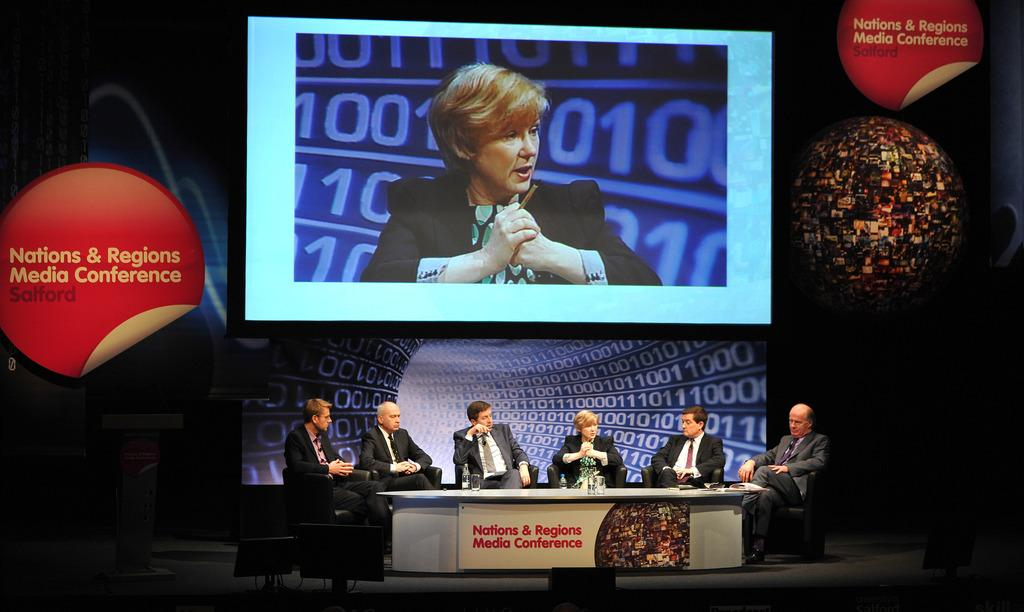<image>
Give a short and clear explanation of the subsequent image. The event here is the Nations & Regions Media Conference 